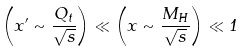<formula> <loc_0><loc_0><loc_500><loc_500>\left ( x ^ { \prime } \sim \frac { Q _ { t } } { \sqrt { s } } \right ) \ll \left ( x \sim \frac { M _ { H } } { \sqrt { s } } \right ) \ll 1</formula> 